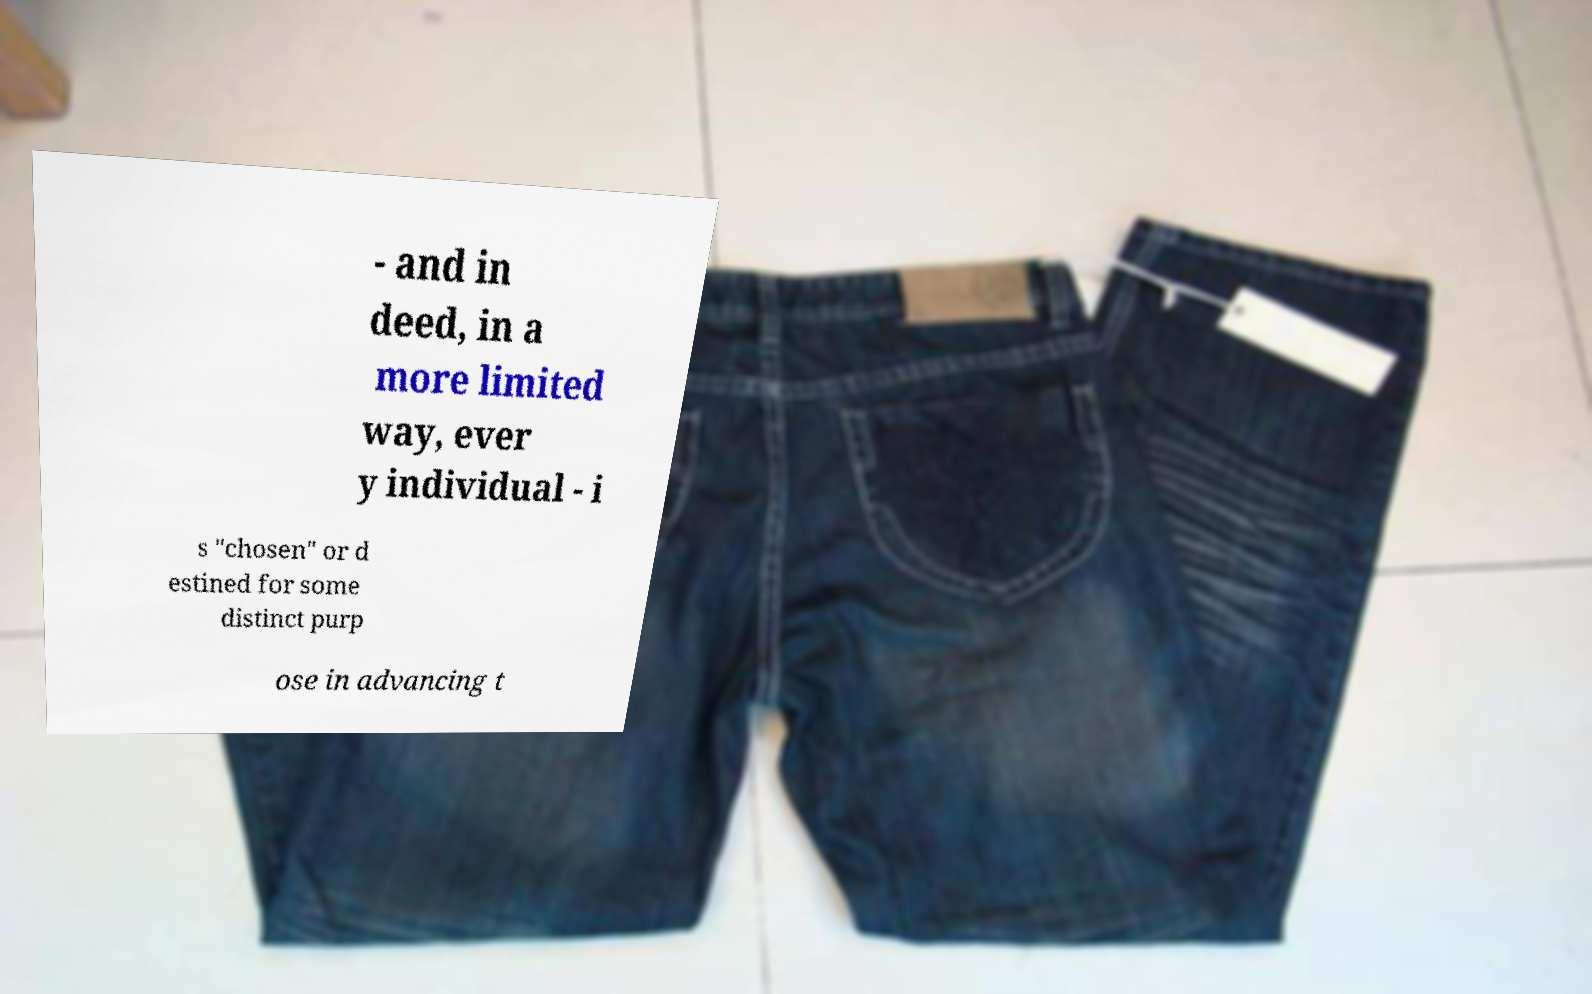There's text embedded in this image that I need extracted. Can you transcribe it verbatim? - and in deed, in a more limited way, ever y individual - i s "chosen" or d estined for some distinct purp ose in advancing t 